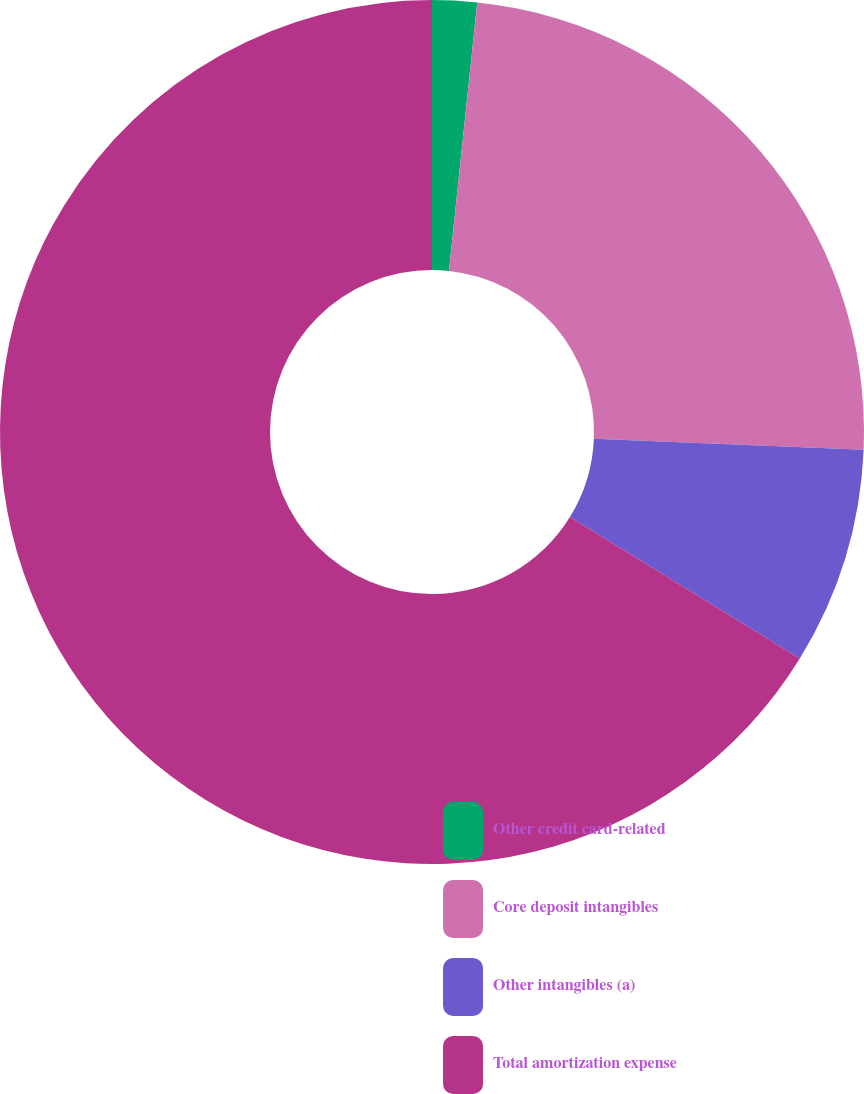<chart> <loc_0><loc_0><loc_500><loc_500><pie_chart><fcel>Other credit card-related<fcel>Core deposit intangibles<fcel>Other intangibles (a)<fcel>Total amortization expense<nl><fcel>1.67%<fcel>23.99%<fcel>8.13%<fcel>66.22%<nl></chart> 